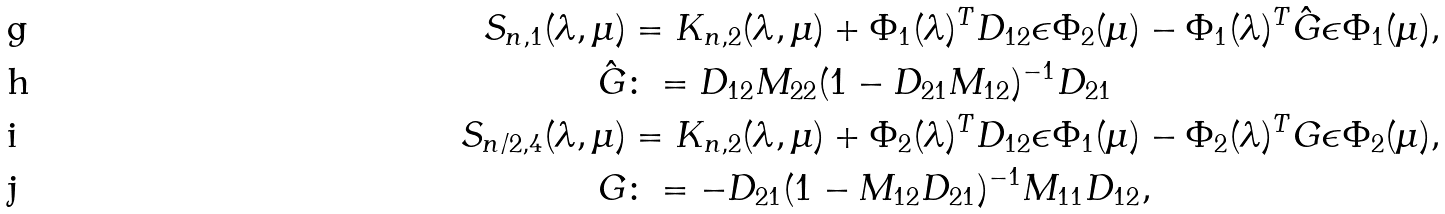<formula> <loc_0><loc_0><loc_500><loc_500>S _ { n , 1 } ( \lambda , \mu ) & = K _ { n , 2 } ( \lambda , \mu ) + \Phi _ { 1 } ( \lambda ) ^ { T } D _ { 1 2 } \epsilon \Phi _ { 2 } ( \mu ) - \Phi _ { 1 } ( \lambda ) ^ { T } \hat { G } \epsilon \Phi _ { 1 } ( \mu ) , \\ \hat { G } & \colon = D _ { 1 2 } M _ { 2 2 } ( 1 - D _ { 2 1 } M _ { 1 2 } ) ^ { - 1 } D _ { 2 1 } \\ S _ { n / 2 , 4 } ( \lambda , \mu ) & = K _ { n , 2 } ( \lambda , \mu ) + \Phi _ { 2 } ( \lambda ) ^ { T } D _ { 1 2 } \epsilon \Phi _ { 1 } ( \mu ) - \Phi _ { 2 } ( \lambda ) ^ { T } G \epsilon \Phi _ { 2 } ( \mu ) , \\ G & \colon = - D _ { 2 1 } ( 1 - M _ { 1 2 } D _ { 2 1 } ) ^ { - 1 } M _ { 1 1 } D _ { 1 2 } ,</formula> 